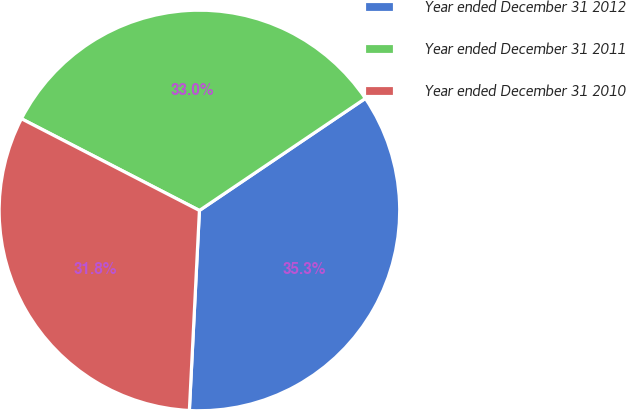Convert chart to OTSL. <chart><loc_0><loc_0><loc_500><loc_500><pie_chart><fcel>Year ended December 31 2012<fcel>Year ended December 31 2011<fcel>Year ended December 31 2010<nl><fcel>35.25%<fcel>32.97%<fcel>31.77%<nl></chart> 